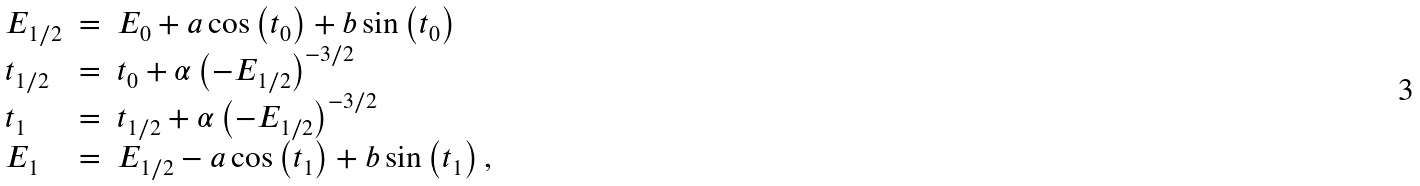Convert formula to latex. <formula><loc_0><loc_0><loc_500><loc_500>\begin{array} { l c l } E _ { 1 / 2 } & = & E _ { 0 } + a \cos \left ( t _ { 0 } \right ) + b \sin \left ( t _ { 0 } \right ) \\ t _ { 1 / 2 } & = & t _ { 0 } + \alpha \left ( - E _ { 1 / 2 } \right ) ^ { - 3 / 2 } \\ t _ { 1 } & = & t _ { 1 / 2 } + \alpha \left ( - E _ { 1 / 2 } \right ) ^ { - 3 / 2 } \\ E _ { 1 } & = & E _ { 1 / 2 } - a \cos \left ( t _ { 1 } \right ) + b \sin \left ( t _ { 1 } \right ) , \end{array}</formula> 